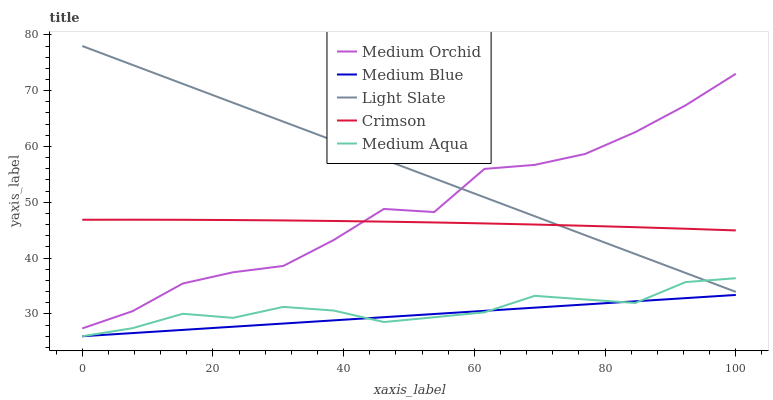Does Medium Blue have the minimum area under the curve?
Answer yes or no. Yes. Does Light Slate have the maximum area under the curve?
Answer yes or no. Yes. Does Crimson have the minimum area under the curve?
Answer yes or no. No. Does Crimson have the maximum area under the curve?
Answer yes or no. No. Is Medium Blue the smoothest?
Answer yes or no. Yes. Is Medium Orchid the roughest?
Answer yes or no. Yes. Is Crimson the smoothest?
Answer yes or no. No. Is Crimson the roughest?
Answer yes or no. No. Does Medium Aqua have the lowest value?
Answer yes or no. Yes. Does Crimson have the lowest value?
Answer yes or no. No. Does Light Slate have the highest value?
Answer yes or no. Yes. Does Crimson have the highest value?
Answer yes or no. No. Is Medium Aqua less than Crimson?
Answer yes or no. Yes. Is Crimson greater than Medium Aqua?
Answer yes or no. Yes. Does Medium Orchid intersect Light Slate?
Answer yes or no. Yes. Is Medium Orchid less than Light Slate?
Answer yes or no. No. Is Medium Orchid greater than Light Slate?
Answer yes or no. No. Does Medium Aqua intersect Crimson?
Answer yes or no. No. 